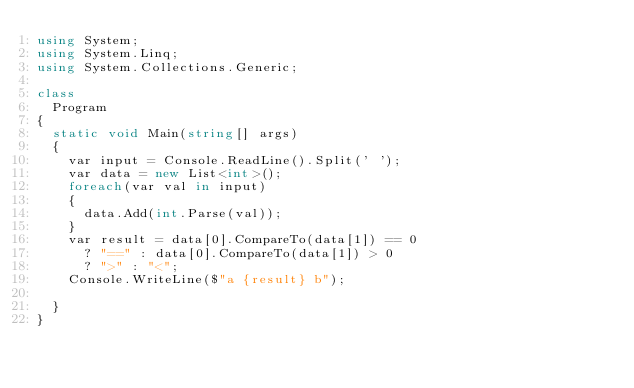Convert code to text. <code><loc_0><loc_0><loc_500><loc_500><_C#_>using System;
using System.Linq;
using System.Collections.Generic;

class
  Program
{
  static void Main(string[] args)
  {
    var input = Console.ReadLine().Split(' ');
    var data = new List<int>();
    foreach(var val in input)
    {
      data.Add(int.Parse(val));
    }
    var result = data[0].CompareTo(data[1]) == 0 
      ? "==" : data[0].CompareTo(data[1]) > 0 
      ? ">" : "<";
    Console.WriteLine($"a {result} b");

  }
}</code> 